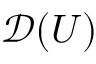Convert formula to latex. <formula><loc_0><loc_0><loc_500><loc_500>{ \mathcal { D } } ( U )</formula> 